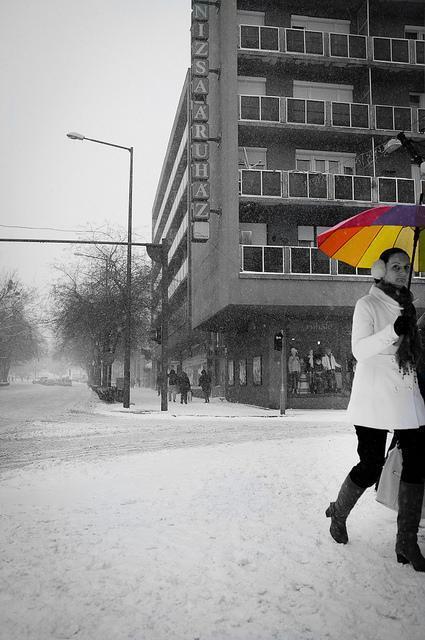How many umbrellas are there?
Give a very brief answer. 1. 